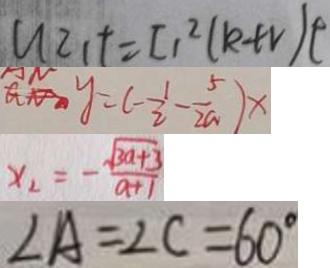<formula> <loc_0><loc_0><loc_500><loc_500>U Z _ { 1 } t = I _ { 1 } ^ { 2 } ( k + v ) t 
 y = ( - \frac { 1 } { 2 } - \frac { 5 } { 2 a } ) x 
 x _ { 2 } = - \frac { \sqrt { 3 a + 3 } } { a + 1 } 
 \angle A = \angle C = 6 0 ^ { \circ }</formula> 